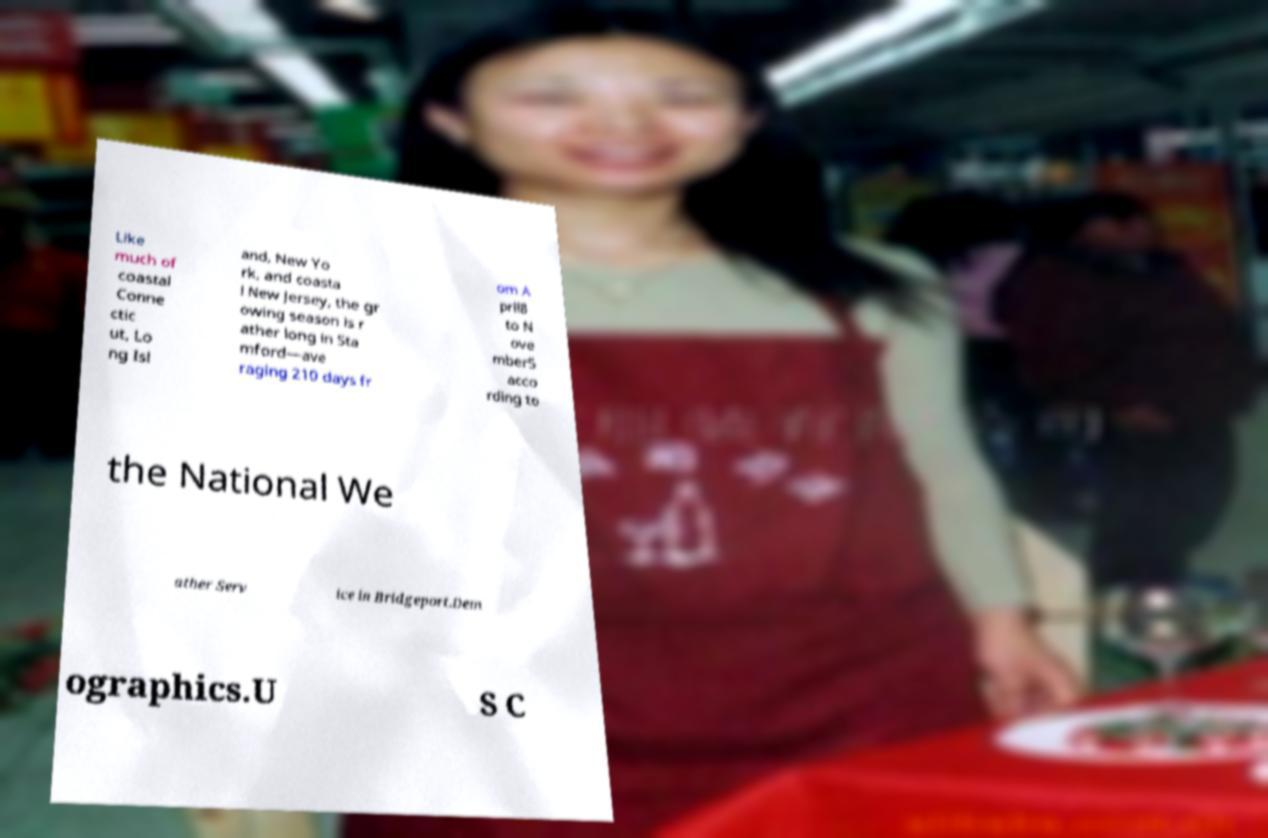Please identify and transcribe the text found in this image. Like much of coastal Conne ctic ut, Lo ng Isl and, New Yo rk, and coasta l New Jersey, the gr owing season is r ather long in Sta mford—ave raging 210 days fr om A pril8 to N ove mber5 acco rding to the National We ather Serv ice in Bridgeport.Dem ographics.U S C 